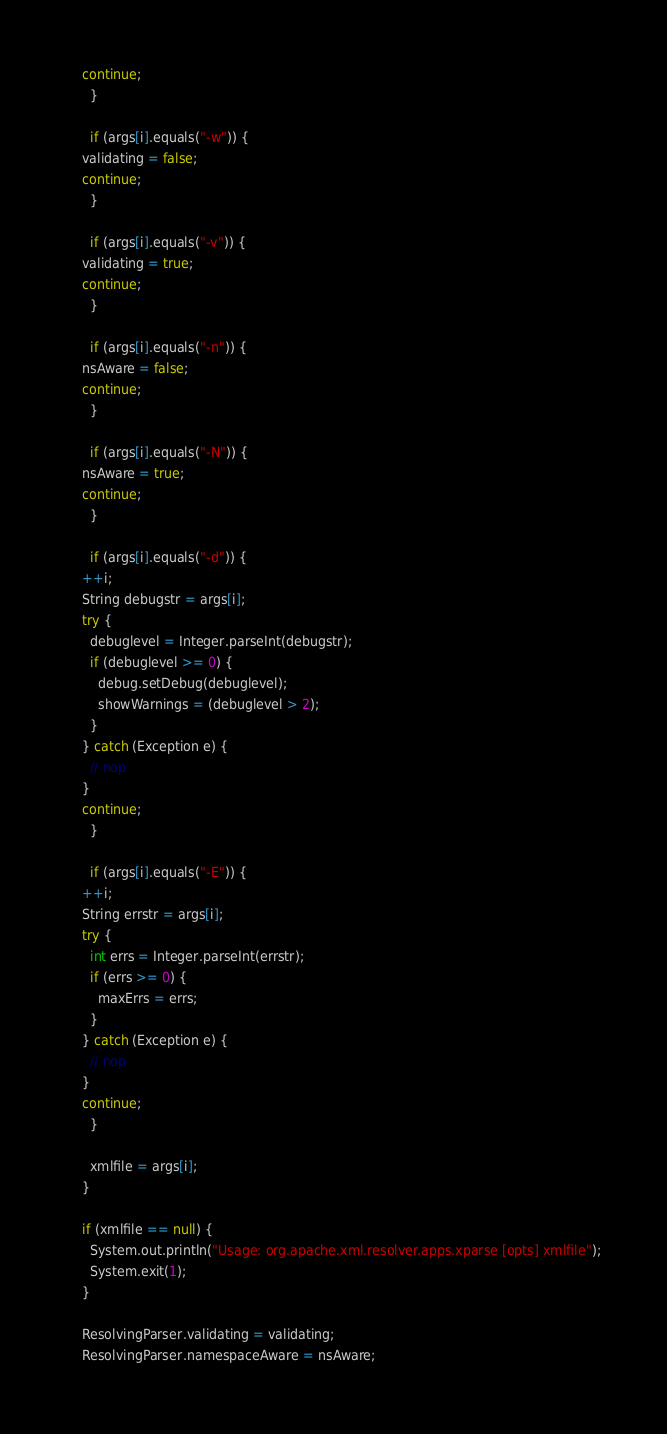Convert code to text. <code><loc_0><loc_0><loc_500><loc_500><_Java_>	continue;
      }

      if (args[i].equals("-w")) {
	validating = false;
	continue;
      }

      if (args[i].equals("-v")) {
	validating = true;
	continue;
      }

      if (args[i].equals("-n")) {
	nsAware = false;
	continue;
      }

      if (args[i].equals("-N")) {
	nsAware = true;
	continue;
      }

      if (args[i].equals("-d")) {
	++i;
	String debugstr = args[i];
	try {
	  debuglevel = Integer.parseInt(debugstr);
	  if (debuglevel >= 0) {
	    debug.setDebug(debuglevel);
	    showWarnings = (debuglevel > 2);
	  }
	} catch (Exception e) {
	  // nop
	}
	continue;
      }

      if (args[i].equals("-E")) {
	++i;
	String errstr = args[i];
	try {
	  int errs = Integer.parseInt(errstr);
	  if (errs >= 0) {
	    maxErrs = errs;
	  }
	} catch (Exception e) {
	  // nop
	}
	continue;
      }

      xmlfile = args[i];
    }

    if (xmlfile == null) {
      System.out.println("Usage: org.apache.xml.resolver.apps.xparse [opts] xmlfile");
      System.exit(1);
    }

    ResolvingParser.validating = validating;
    ResolvingParser.namespaceAware = nsAware;</code> 